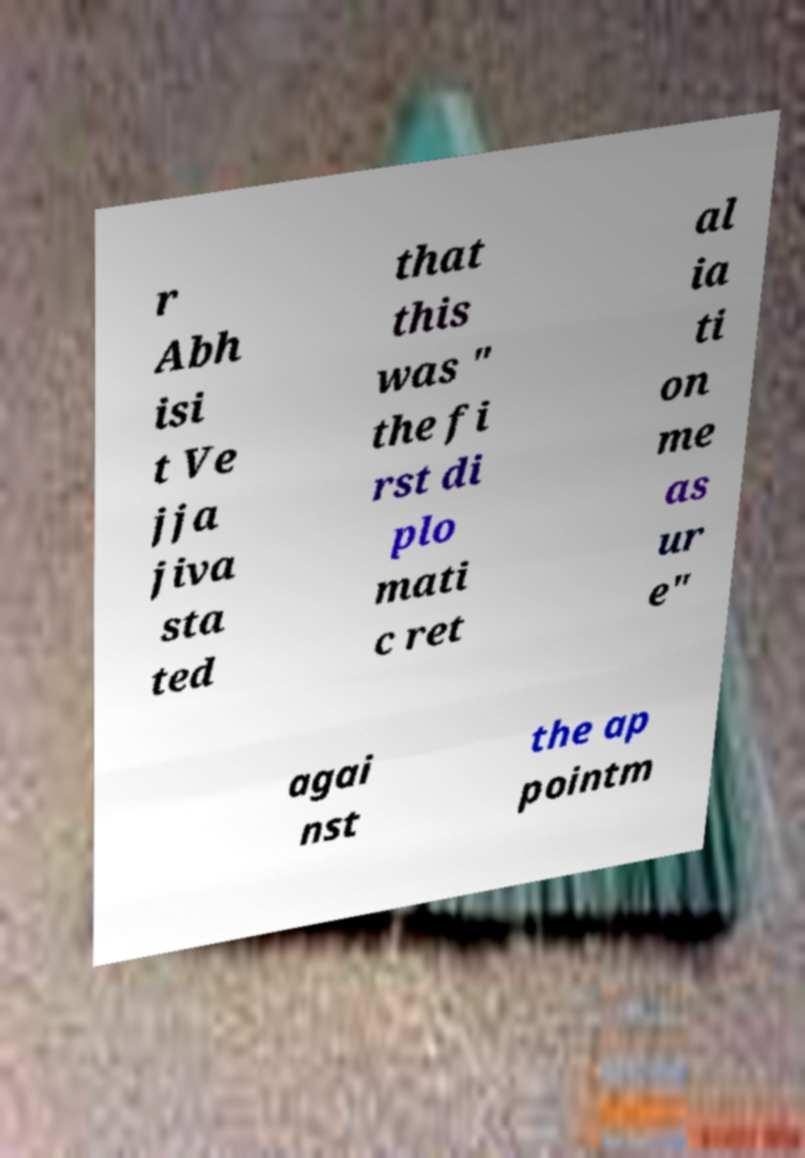What messages or text are displayed in this image? I need them in a readable, typed format. r Abh isi t Ve jja jiva sta ted that this was " the fi rst di plo mati c ret al ia ti on me as ur e" agai nst the ap pointm 